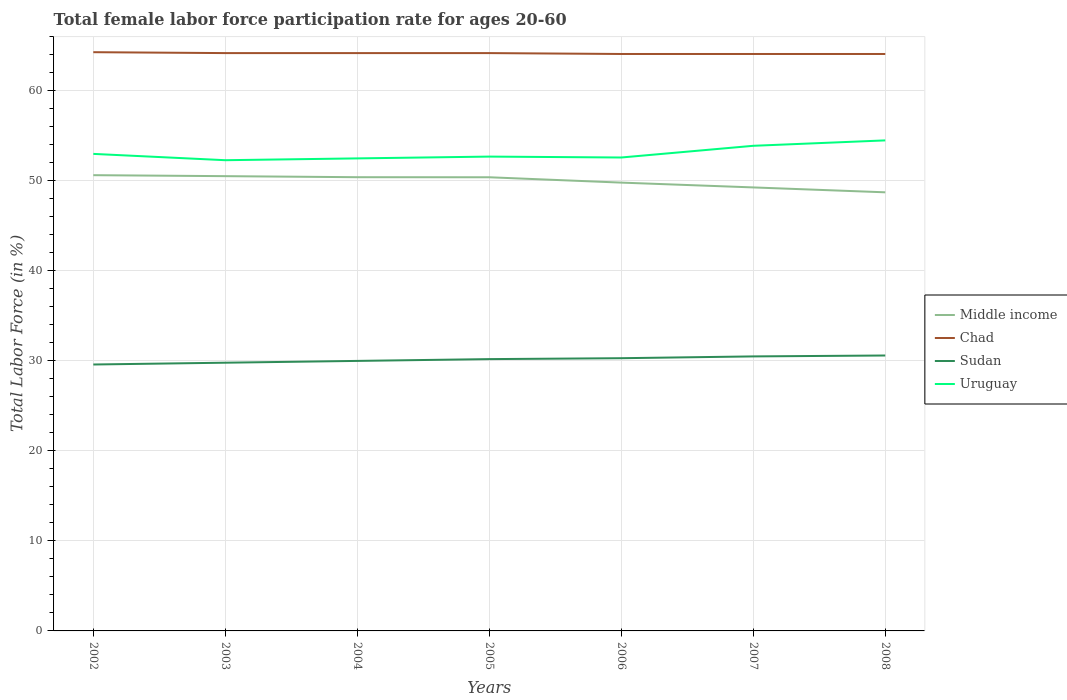How many different coloured lines are there?
Your response must be concise. 4. Does the line corresponding to Uruguay intersect with the line corresponding to Middle income?
Keep it short and to the point. No. Is the number of lines equal to the number of legend labels?
Provide a short and direct response. Yes. Across all years, what is the maximum female labor force participation rate in Chad?
Your answer should be compact. 64.1. What is the total female labor force participation rate in Middle income in the graph?
Offer a terse response. 0.01. What is the difference between the highest and the second highest female labor force participation rate in Chad?
Ensure brevity in your answer.  0.2. What is the difference between the highest and the lowest female labor force participation rate in Chad?
Keep it short and to the point. 4. Is the female labor force participation rate in Chad strictly greater than the female labor force participation rate in Middle income over the years?
Your answer should be very brief. No. Are the values on the major ticks of Y-axis written in scientific E-notation?
Ensure brevity in your answer.  No. Where does the legend appear in the graph?
Provide a succinct answer. Center right. How are the legend labels stacked?
Offer a terse response. Vertical. What is the title of the graph?
Your answer should be very brief. Total female labor force participation rate for ages 20-60. What is the label or title of the X-axis?
Ensure brevity in your answer.  Years. What is the Total Labor Force (in %) in Middle income in 2002?
Offer a very short reply. 50.64. What is the Total Labor Force (in %) in Chad in 2002?
Offer a terse response. 64.3. What is the Total Labor Force (in %) in Sudan in 2002?
Provide a short and direct response. 29.6. What is the Total Labor Force (in %) in Middle income in 2003?
Offer a very short reply. 50.53. What is the Total Labor Force (in %) in Chad in 2003?
Offer a terse response. 64.2. What is the Total Labor Force (in %) in Sudan in 2003?
Give a very brief answer. 29.8. What is the Total Labor Force (in %) of Uruguay in 2003?
Provide a short and direct response. 52.3. What is the Total Labor Force (in %) in Middle income in 2004?
Offer a very short reply. 50.41. What is the Total Labor Force (in %) of Chad in 2004?
Give a very brief answer. 64.2. What is the Total Labor Force (in %) of Sudan in 2004?
Provide a succinct answer. 30. What is the Total Labor Force (in %) in Uruguay in 2004?
Offer a terse response. 52.5. What is the Total Labor Force (in %) of Middle income in 2005?
Make the answer very short. 50.4. What is the Total Labor Force (in %) in Chad in 2005?
Offer a very short reply. 64.2. What is the Total Labor Force (in %) of Sudan in 2005?
Offer a very short reply. 30.2. What is the Total Labor Force (in %) in Uruguay in 2005?
Offer a terse response. 52.7. What is the Total Labor Force (in %) in Middle income in 2006?
Make the answer very short. 49.81. What is the Total Labor Force (in %) in Chad in 2006?
Keep it short and to the point. 64.1. What is the Total Labor Force (in %) in Sudan in 2006?
Provide a succinct answer. 30.3. What is the Total Labor Force (in %) of Uruguay in 2006?
Offer a very short reply. 52.6. What is the Total Labor Force (in %) of Middle income in 2007?
Offer a terse response. 49.28. What is the Total Labor Force (in %) of Chad in 2007?
Offer a terse response. 64.1. What is the Total Labor Force (in %) of Sudan in 2007?
Make the answer very short. 30.5. What is the Total Labor Force (in %) of Uruguay in 2007?
Make the answer very short. 53.9. What is the Total Labor Force (in %) of Middle income in 2008?
Your answer should be very brief. 48.73. What is the Total Labor Force (in %) in Chad in 2008?
Provide a succinct answer. 64.1. What is the Total Labor Force (in %) of Sudan in 2008?
Your answer should be compact. 30.6. What is the Total Labor Force (in %) in Uruguay in 2008?
Your answer should be very brief. 54.5. Across all years, what is the maximum Total Labor Force (in %) in Middle income?
Provide a succinct answer. 50.64. Across all years, what is the maximum Total Labor Force (in %) of Chad?
Your answer should be compact. 64.3. Across all years, what is the maximum Total Labor Force (in %) in Sudan?
Offer a terse response. 30.6. Across all years, what is the maximum Total Labor Force (in %) in Uruguay?
Provide a short and direct response. 54.5. Across all years, what is the minimum Total Labor Force (in %) of Middle income?
Provide a short and direct response. 48.73. Across all years, what is the minimum Total Labor Force (in %) in Chad?
Provide a short and direct response. 64.1. Across all years, what is the minimum Total Labor Force (in %) of Sudan?
Make the answer very short. 29.6. Across all years, what is the minimum Total Labor Force (in %) in Uruguay?
Your answer should be very brief. 52.3. What is the total Total Labor Force (in %) of Middle income in the graph?
Provide a short and direct response. 349.8. What is the total Total Labor Force (in %) in Chad in the graph?
Offer a terse response. 449.2. What is the total Total Labor Force (in %) of Sudan in the graph?
Your response must be concise. 211. What is the total Total Labor Force (in %) in Uruguay in the graph?
Ensure brevity in your answer.  371.5. What is the difference between the Total Labor Force (in %) in Middle income in 2002 and that in 2003?
Offer a very short reply. 0.11. What is the difference between the Total Labor Force (in %) of Uruguay in 2002 and that in 2003?
Provide a succinct answer. 0.7. What is the difference between the Total Labor Force (in %) of Middle income in 2002 and that in 2004?
Make the answer very short. 0.23. What is the difference between the Total Labor Force (in %) of Chad in 2002 and that in 2004?
Keep it short and to the point. 0.1. What is the difference between the Total Labor Force (in %) of Uruguay in 2002 and that in 2004?
Provide a short and direct response. 0.5. What is the difference between the Total Labor Force (in %) of Middle income in 2002 and that in 2005?
Your answer should be compact. 0.23. What is the difference between the Total Labor Force (in %) of Middle income in 2002 and that in 2006?
Keep it short and to the point. 0.83. What is the difference between the Total Labor Force (in %) in Middle income in 2002 and that in 2007?
Keep it short and to the point. 1.36. What is the difference between the Total Labor Force (in %) of Sudan in 2002 and that in 2007?
Keep it short and to the point. -0.9. What is the difference between the Total Labor Force (in %) of Uruguay in 2002 and that in 2007?
Your answer should be very brief. -0.9. What is the difference between the Total Labor Force (in %) of Middle income in 2002 and that in 2008?
Your answer should be compact. 1.9. What is the difference between the Total Labor Force (in %) of Sudan in 2002 and that in 2008?
Offer a very short reply. -1. What is the difference between the Total Labor Force (in %) of Middle income in 2003 and that in 2004?
Keep it short and to the point. 0.12. What is the difference between the Total Labor Force (in %) in Chad in 2003 and that in 2004?
Give a very brief answer. 0. What is the difference between the Total Labor Force (in %) of Sudan in 2003 and that in 2004?
Make the answer very short. -0.2. What is the difference between the Total Labor Force (in %) of Uruguay in 2003 and that in 2004?
Keep it short and to the point. -0.2. What is the difference between the Total Labor Force (in %) of Middle income in 2003 and that in 2005?
Your answer should be very brief. 0.12. What is the difference between the Total Labor Force (in %) in Chad in 2003 and that in 2005?
Offer a terse response. 0. What is the difference between the Total Labor Force (in %) of Middle income in 2003 and that in 2006?
Provide a succinct answer. 0.72. What is the difference between the Total Labor Force (in %) in Chad in 2003 and that in 2006?
Provide a succinct answer. 0.1. What is the difference between the Total Labor Force (in %) of Uruguay in 2003 and that in 2006?
Your answer should be compact. -0.3. What is the difference between the Total Labor Force (in %) in Middle income in 2003 and that in 2007?
Ensure brevity in your answer.  1.25. What is the difference between the Total Labor Force (in %) in Chad in 2003 and that in 2007?
Your answer should be compact. 0.1. What is the difference between the Total Labor Force (in %) in Sudan in 2003 and that in 2007?
Offer a terse response. -0.7. What is the difference between the Total Labor Force (in %) of Middle income in 2003 and that in 2008?
Make the answer very short. 1.8. What is the difference between the Total Labor Force (in %) of Chad in 2003 and that in 2008?
Keep it short and to the point. 0.1. What is the difference between the Total Labor Force (in %) of Sudan in 2003 and that in 2008?
Ensure brevity in your answer.  -0.8. What is the difference between the Total Labor Force (in %) of Middle income in 2004 and that in 2005?
Your answer should be very brief. 0.01. What is the difference between the Total Labor Force (in %) of Chad in 2004 and that in 2005?
Your response must be concise. 0. What is the difference between the Total Labor Force (in %) of Sudan in 2004 and that in 2005?
Offer a terse response. -0.2. What is the difference between the Total Labor Force (in %) of Middle income in 2004 and that in 2006?
Offer a terse response. 0.6. What is the difference between the Total Labor Force (in %) of Chad in 2004 and that in 2006?
Make the answer very short. 0.1. What is the difference between the Total Labor Force (in %) in Middle income in 2004 and that in 2007?
Keep it short and to the point. 1.14. What is the difference between the Total Labor Force (in %) in Sudan in 2004 and that in 2007?
Provide a short and direct response. -0.5. What is the difference between the Total Labor Force (in %) in Middle income in 2004 and that in 2008?
Offer a very short reply. 1.68. What is the difference between the Total Labor Force (in %) in Sudan in 2004 and that in 2008?
Offer a very short reply. -0.6. What is the difference between the Total Labor Force (in %) of Middle income in 2005 and that in 2006?
Your answer should be compact. 0.59. What is the difference between the Total Labor Force (in %) in Uruguay in 2005 and that in 2006?
Offer a terse response. 0.1. What is the difference between the Total Labor Force (in %) of Middle income in 2005 and that in 2007?
Make the answer very short. 1.13. What is the difference between the Total Labor Force (in %) in Chad in 2005 and that in 2007?
Provide a succinct answer. 0.1. What is the difference between the Total Labor Force (in %) of Middle income in 2005 and that in 2008?
Your answer should be compact. 1.67. What is the difference between the Total Labor Force (in %) of Chad in 2005 and that in 2008?
Your answer should be compact. 0.1. What is the difference between the Total Labor Force (in %) of Sudan in 2005 and that in 2008?
Your response must be concise. -0.4. What is the difference between the Total Labor Force (in %) of Uruguay in 2005 and that in 2008?
Your response must be concise. -1.8. What is the difference between the Total Labor Force (in %) of Middle income in 2006 and that in 2007?
Keep it short and to the point. 0.53. What is the difference between the Total Labor Force (in %) in Middle income in 2006 and that in 2008?
Provide a short and direct response. 1.08. What is the difference between the Total Labor Force (in %) in Sudan in 2006 and that in 2008?
Keep it short and to the point. -0.3. What is the difference between the Total Labor Force (in %) of Middle income in 2007 and that in 2008?
Offer a very short reply. 0.54. What is the difference between the Total Labor Force (in %) of Sudan in 2007 and that in 2008?
Make the answer very short. -0.1. What is the difference between the Total Labor Force (in %) of Middle income in 2002 and the Total Labor Force (in %) of Chad in 2003?
Your answer should be compact. -13.56. What is the difference between the Total Labor Force (in %) of Middle income in 2002 and the Total Labor Force (in %) of Sudan in 2003?
Your response must be concise. 20.84. What is the difference between the Total Labor Force (in %) in Middle income in 2002 and the Total Labor Force (in %) in Uruguay in 2003?
Your answer should be compact. -1.66. What is the difference between the Total Labor Force (in %) in Chad in 2002 and the Total Labor Force (in %) in Sudan in 2003?
Give a very brief answer. 34.5. What is the difference between the Total Labor Force (in %) of Chad in 2002 and the Total Labor Force (in %) of Uruguay in 2003?
Keep it short and to the point. 12. What is the difference between the Total Labor Force (in %) in Sudan in 2002 and the Total Labor Force (in %) in Uruguay in 2003?
Keep it short and to the point. -22.7. What is the difference between the Total Labor Force (in %) in Middle income in 2002 and the Total Labor Force (in %) in Chad in 2004?
Your answer should be very brief. -13.56. What is the difference between the Total Labor Force (in %) in Middle income in 2002 and the Total Labor Force (in %) in Sudan in 2004?
Your answer should be compact. 20.64. What is the difference between the Total Labor Force (in %) in Middle income in 2002 and the Total Labor Force (in %) in Uruguay in 2004?
Make the answer very short. -1.86. What is the difference between the Total Labor Force (in %) in Chad in 2002 and the Total Labor Force (in %) in Sudan in 2004?
Make the answer very short. 34.3. What is the difference between the Total Labor Force (in %) of Sudan in 2002 and the Total Labor Force (in %) of Uruguay in 2004?
Your response must be concise. -22.9. What is the difference between the Total Labor Force (in %) in Middle income in 2002 and the Total Labor Force (in %) in Chad in 2005?
Provide a succinct answer. -13.56. What is the difference between the Total Labor Force (in %) in Middle income in 2002 and the Total Labor Force (in %) in Sudan in 2005?
Your answer should be compact. 20.44. What is the difference between the Total Labor Force (in %) of Middle income in 2002 and the Total Labor Force (in %) of Uruguay in 2005?
Offer a terse response. -2.06. What is the difference between the Total Labor Force (in %) in Chad in 2002 and the Total Labor Force (in %) in Sudan in 2005?
Give a very brief answer. 34.1. What is the difference between the Total Labor Force (in %) of Chad in 2002 and the Total Labor Force (in %) of Uruguay in 2005?
Make the answer very short. 11.6. What is the difference between the Total Labor Force (in %) in Sudan in 2002 and the Total Labor Force (in %) in Uruguay in 2005?
Your response must be concise. -23.1. What is the difference between the Total Labor Force (in %) in Middle income in 2002 and the Total Labor Force (in %) in Chad in 2006?
Provide a short and direct response. -13.46. What is the difference between the Total Labor Force (in %) of Middle income in 2002 and the Total Labor Force (in %) of Sudan in 2006?
Offer a very short reply. 20.34. What is the difference between the Total Labor Force (in %) of Middle income in 2002 and the Total Labor Force (in %) of Uruguay in 2006?
Offer a very short reply. -1.96. What is the difference between the Total Labor Force (in %) of Chad in 2002 and the Total Labor Force (in %) of Sudan in 2006?
Provide a short and direct response. 34. What is the difference between the Total Labor Force (in %) in Sudan in 2002 and the Total Labor Force (in %) in Uruguay in 2006?
Your response must be concise. -23. What is the difference between the Total Labor Force (in %) in Middle income in 2002 and the Total Labor Force (in %) in Chad in 2007?
Your answer should be very brief. -13.46. What is the difference between the Total Labor Force (in %) of Middle income in 2002 and the Total Labor Force (in %) of Sudan in 2007?
Provide a short and direct response. 20.14. What is the difference between the Total Labor Force (in %) in Middle income in 2002 and the Total Labor Force (in %) in Uruguay in 2007?
Ensure brevity in your answer.  -3.26. What is the difference between the Total Labor Force (in %) in Chad in 2002 and the Total Labor Force (in %) in Sudan in 2007?
Offer a terse response. 33.8. What is the difference between the Total Labor Force (in %) in Sudan in 2002 and the Total Labor Force (in %) in Uruguay in 2007?
Offer a very short reply. -24.3. What is the difference between the Total Labor Force (in %) in Middle income in 2002 and the Total Labor Force (in %) in Chad in 2008?
Give a very brief answer. -13.46. What is the difference between the Total Labor Force (in %) in Middle income in 2002 and the Total Labor Force (in %) in Sudan in 2008?
Your answer should be compact. 20.04. What is the difference between the Total Labor Force (in %) in Middle income in 2002 and the Total Labor Force (in %) in Uruguay in 2008?
Offer a very short reply. -3.86. What is the difference between the Total Labor Force (in %) in Chad in 2002 and the Total Labor Force (in %) in Sudan in 2008?
Give a very brief answer. 33.7. What is the difference between the Total Labor Force (in %) in Sudan in 2002 and the Total Labor Force (in %) in Uruguay in 2008?
Your response must be concise. -24.9. What is the difference between the Total Labor Force (in %) of Middle income in 2003 and the Total Labor Force (in %) of Chad in 2004?
Make the answer very short. -13.67. What is the difference between the Total Labor Force (in %) of Middle income in 2003 and the Total Labor Force (in %) of Sudan in 2004?
Your answer should be very brief. 20.53. What is the difference between the Total Labor Force (in %) of Middle income in 2003 and the Total Labor Force (in %) of Uruguay in 2004?
Offer a very short reply. -1.97. What is the difference between the Total Labor Force (in %) of Chad in 2003 and the Total Labor Force (in %) of Sudan in 2004?
Your response must be concise. 34.2. What is the difference between the Total Labor Force (in %) in Sudan in 2003 and the Total Labor Force (in %) in Uruguay in 2004?
Ensure brevity in your answer.  -22.7. What is the difference between the Total Labor Force (in %) of Middle income in 2003 and the Total Labor Force (in %) of Chad in 2005?
Your response must be concise. -13.67. What is the difference between the Total Labor Force (in %) in Middle income in 2003 and the Total Labor Force (in %) in Sudan in 2005?
Your answer should be compact. 20.33. What is the difference between the Total Labor Force (in %) of Middle income in 2003 and the Total Labor Force (in %) of Uruguay in 2005?
Offer a very short reply. -2.17. What is the difference between the Total Labor Force (in %) of Sudan in 2003 and the Total Labor Force (in %) of Uruguay in 2005?
Your answer should be compact. -22.9. What is the difference between the Total Labor Force (in %) in Middle income in 2003 and the Total Labor Force (in %) in Chad in 2006?
Provide a succinct answer. -13.57. What is the difference between the Total Labor Force (in %) in Middle income in 2003 and the Total Labor Force (in %) in Sudan in 2006?
Make the answer very short. 20.23. What is the difference between the Total Labor Force (in %) of Middle income in 2003 and the Total Labor Force (in %) of Uruguay in 2006?
Keep it short and to the point. -2.07. What is the difference between the Total Labor Force (in %) of Chad in 2003 and the Total Labor Force (in %) of Sudan in 2006?
Offer a terse response. 33.9. What is the difference between the Total Labor Force (in %) in Sudan in 2003 and the Total Labor Force (in %) in Uruguay in 2006?
Keep it short and to the point. -22.8. What is the difference between the Total Labor Force (in %) of Middle income in 2003 and the Total Labor Force (in %) of Chad in 2007?
Provide a succinct answer. -13.57. What is the difference between the Total Labor Force (in %) in Middle income in 2003 and the Total Labor Force (in %) in Sudan in 2007?
Give a very brief answer. 20.03. What is the difference between the Total Labor Force (in %) in Middle income in 2003 and the Total Labor Force (in %) in Uruguay in 2007?
Give a very brief answer. -3.37. What is the difference between the Total Labor Force (in %) of Chad in 2003 and the Total Labor Force (in %) of Sudan in 2007?
Your answer should be compact. 33.7. What is the difference between the Total Labor Force (in %) in Chad in 2003 and the Total Labor Force (in %) in Uruguay in 2007?
Ensure brevity in your answer.  10.3. What is the difference between the Total Labor Force (in %) in Sudan in 2003 and the Total Labor Force (in %) in Uruguay in 2007?
Give a very brief answer. -24.1. What is the difference between the Total Labor Force (in %) in Middle income in 2003 and the Total Labor Force (in %) in Chad in 2008?
Give a very brief answer. -13.57. What is the difference between the Total Labor Force (in %) in Middle income in 2003 and the Total Labor Force (in %) in Sudan in 2008?
Provide a short and direct response. 19.93. What is the difference between the Total Labor Force (in %) in Middle income in 2003 and the Total Labor Force (in %) in Uruguay in 2008?
Provide a succinct answer. -3.97. What is the difference between the Total Labor Force (in %) in Chad in 2003 and the Total Labor Force (in %) in Sudan in 2008?
Your response must be concise. 33.6. What is the difference between the Total Labor Force (in %) of Sudan in 2003 and the Total Labor Force (in %) of Uruguay in 2008?
Keep it short and to the point. -24.7. What is the difference between the Total Labor Force (in %) of Middle income in 2004 and the Total Labor Force (in %) of Chad in 2005?
Make the answer very short. -13.79. What is the difference between the Total Labor Force (in %) in Middle income in 2004 and the Total Labor Force (in %) in Sudan in 2005?
Provide a short and direct response. 20.21. What is the difference between the Total Labor Force (in %) in Middle income in 2004 and the Total Labor Force (in %) in Uruguay in 2005?
Ensure brevity in your answer.  -2.29. What is the difference between the Total Labor Force (in %) in Chad in 2004 and the Total Labor Force (in %) in Sudan in 2005?
Keep it short and to the point. 34. What is the difference between the Total Labor Force (in %) of Sudan in 2004 and the Total Labor Force (in %) of Uruguay in 2005?
Your answer should be very brief. -22.7. What is the difference between the Total Labor Force (in %) of Middle income in 2004 and the Total Labor Force (in %) of Chad in 2006?
Keep it short and to the point. -13.69. What is the difference between the Total Labor Force (in %) in Middle income in 2004 and the Total Labor Force (in %) in Sudan in 2006?
Offer a very short reply. 20.11. What is the difference between the Total Labor Force (in %) of Middle income in 2004 and the Total Labor Force (in %) of Uruguay in 2006?
Offer a terse response. -2.19. What is the difference between the Total Labor Force (in %) of Chad in 2004 and the Total Labor Force (in %) of Sudan in 2006?
Give a very brief answer. 33.9. What is the difference between the Total Labor Force (in %) of Chad in 2004 and the Total Labor Force (in %) of Uruguay in 2006?
Give a very brief answer. 11.6. What is the difference between the Total Labor Force (in %) in Sudan in 2004 and the Total Labor Force (in %) in Uruguay in 2006?
Give a very brief answer. -22.6. What is the difference between the Total Labor Force (in %) in Middle income in 2004 and the Total Labor Force (in %) in Chad in 2007?
Provide a short and direct response. -13.69. What is the difference between the Total Labor Force (in %) of Middle income in 2004 and the Total Labor Force (in %) of Sudan in 2007?
Provide a succinct answer. 19.91. What is the difference between the Total Labor Force (in %) of Middle income in 2004 and the Total Labor Force (in %) of Uruguay in 2007?
Your response must be concise. -3.49. What is the difference between the Total Labor Force (in %) of Chad in 2004 and the Total Labor Force (in %) of Sudan in 2007?
Offer a very short reply. 33.7. What is the difference between the Total Labor Force (in %) in Sudan in 2004 and the Total Labor Force (in %) in Uruguay in 2007?
Ensure brevity in your answer.  -23.9. What is the difference between the Total Labor Force (in %) of Middle income in 2004 and the Total Labor Force (in %) of Chad in 2008?
Make the answer very short. -13.69. What is the difference between the Total Labor Force (in %) of Middle income in 2004 and the Total Labor Force (in %) of Sudan in 2008?
Give a very brief answer. 19.81. What is the difference between the Total Labor Force (in %) of Middle income in 2004 and the Total Labor Force (in %) of Uruguay in 2008?
Your answer should be very brief. -4.09. What is the difference between the Total Labor Force (in %) of Chad in 2004 and the Total Labor Force (in %) of Sudan in 2008?
Offer a very short reply. 33.6. What is the difference between the Total Labor Force (in %) of Sudan in 2004 and the Total Labor Force (in %) of Uruguay in 2008?
Your response must be concise. -24.5. What is the difference between the Total Labor Force (in %) of Middle income in 2005 and the Total Labor Force (in %) of Chad in 2006?
Your answer should be very brief. -13.7. What is the difference between the Total Labor Force (in %) in Middle income in 2005 and the Total Labor Force (in %) in Sudan in 2006?
Offer a very short reply. 20.1. What is the difference between the Total Labor Force (in %) in Middle income in 2005 and the Total Labor Force (in %) in Uruguay in 2006?
Your answer should be very brief. -2.2. What is the difference between the Total Labor Force (in %) of Chad in 2005 and the Total Labor Force (in %) of Sudan in 2006?
Your answer should be compact. 33.9. What is the difference between the Total Labor Force (in %) of Sudan in 2005 and the Total Labor Force (in %) of Uruguay in 2006?
Your answer should be compact. -22.4. What is the difference between the Total Labor Force (in %) of Middle income in 2005 and the Total Labor Force (in %) of Chad in 2007?
Provide a short and direct response. -13.7. What is the difference between the Total Labor Force (in %) of Middle income in 2005 and the Total Labor Force (in %) of Sudan in 2007?
Ensure brevity in your answer.  19.9. What is the difference between the Total Labor Force (in %) in Middle income in 2005 and the Total Labor Force (in %) in Uruguay in 2007?
Provide a succinct answer. -3.5. What is the difference between the Total Labor Force (in %) of Chad in 2005 and the Total Labor Force (in %) of Sudan in 2007?
Provide a succinct answer. 33.7. What is the difference between the Total Labor Force (in %) in Sudan in 2005 and the Total Labor Force (in %) in Uruguay in 2007?
Your answer should be compact. -23.7. What is the difference between the Total Labor Force (in %) in Middle income in 2005 and the Total Labor Force (in %) in Chad in 2008?
Your answer should be compact. -13.7. What is the difference between the Total Labor Force (in %) of Middle income in 2005 and the Total Labor Force (in %) of Sudan in 2008?
Provide a short and direct response. 19.8. What is the difference between the Total Labor Force (in %) in Middle income in 2005 and the Total Labor Force (in %) in Uruguay in 2008?
Your response must be concise. -4.1. What is the difference between the Total Labor Force (in %) in Chad in 2005 and the Total Labor Force (in %) in Sudan in 2008?
Offer a terse response. 33.6. What is the difference between the Total Labor Force (in %) of Sudan in 2005 and the Total Labor Force (in %) of Uruguay in 2008?
Your answer should be very brief. -24.3. What is the difference between the Total Labor Force (in %) in Middle income in 2006 and the Total Labor Force (in %) in Chad in 2007?
Your answer should be compact. -14.29. What is the difference between the Total Labor Force (in %) of Middle income in 2006 and the Total Labor Force (in %) of Sudan in 2007?
Ensure brevity in your answer.  19.31. What is the difference between the Total Labor Force (in %) of Middle income in 2006 and the Total Labor Force (in %) of Uruguay in 2007?
Provide a short and direct response. -4.09. What is the difference between the Total Labor Force (in %) in Chad in 2006 and the Total Labor Force (in %) in Sudan in 2007?
Provide a short and direct response. 33.6. What is the difference between the Total Labor Force (in %) of Sudan in 2006 and the Total Labor Force (in %) of Uruguay in 2007?
Offer a terse response. -23.6. What is the difference between the Total Labor Force (in %) in Middle income in 2006 and the Total Labor Force (in %) in Chad in 2008?
Provide a succinct answer. -14.29. What is the difference between the Total Labor Force (in %) of Middle income in 2006 and the Total Labor Force (in %) of Sudan in 2008?
Provide a succinct answer. 19.21. What is the difference between the Total Labor Force (in %) in Middle income in 2006 and the Total Labor Force (in %) in Uruguay in 2008?
Provide a succinct answer. -4.69. What is the difference between the Total Labor Force (in %) of Chad in 2006 and the Total Labor Force (in %) of Sudan in 2008?
Keep it short and to the point. 33.5. What is the difference between the Total Labor Force (in %) of Sudan in 2006 and the Total Labor Force (in %) of Uruguay in 2008?
Provide a short and direct response. -24.2. What is the difference between the Total Labor Force (in %) of Middle income in 2007 and the Total Labor Force (in %) of Chad in 2008?
Offer a very short reply. -14.82. What is the difference between the Total Labor Force (in %) of Middle income in 2007 and the Total Labor Force (in %) of Sudan in 2008?
Give a very brief answer. 18.68. What is the difference between the Total Labor Force (in %) of Middle income in 2007 and the Total Labor Force (in %) of Uruguay in 2008?
Offer a terse response. -5.22. What is the difference between the Total Labor Force (in %) in Chad in 2007 and the Total Labor Force (in %) in Sudan in 2008?
Provide a short and direct response. 33.5. What is the difference between the Total Labor Force (in %) of Chad in 2007 and the Total Labor Force (in %) of Uruguay in 2008?
Your answer should be very brief. 9.6. What is the average Total Labor Force (in %) of Middle income per year?
Give a very brief answer. 49.97. What is the average Total Labor Force (in %) of Chad per year?
Offer a terse response. 64.17. What is the average Total Labor Force (in %) of Sudan per year?
Your answer should be compact. 30.14. What is the average Total Labor Force (in %) in Uruguay per year?
Your answer should be compact. 53.07. In the year 2002, what is the difference between the Total Labor Force (in %) in Middle income and Total Labor Force (in %) in Chad?
Provide a succinct answer. -13.66. In the year 2002, what is the difference between the Total Labor Force (in %) of Middle income and Total Labor Force (in %) of Sudan?
Ensure brevity in your answer.  21.04. In the year 2002, what is the difference between the Total Labor Force (in %) of Middle income and Total Labor Force (in %) of Uruguay?
Your response must be concise. -2.36. In the year 2002, what is the difference between the Total Labor Force (in %) of Chad and Total Labor Force (in %) of Sudan?
Provide a succinct answer. 34.7. In the year 2002, what is the difference between the Total Labor Force (in %) in Chad and Total Labor Force (in %) in Uruguay?
Provide a short and direct response. 11.3. In the year 2002, what is the difference between the Total Labor Force (in %) of Sudan and Total Labor Force (in %) of Uruguay?
Give a very brief answer. -23.4. In the year 2003, what is the difference between the Total Labor Force (in %) in Middle income and Total Labor Force (in %) in Chad?
Offer a very short reply. -13.67. In the year 2003, what is the difference between the Total Labor Force (in %) in Middle income and Total Labor Force (in %) in Sudan?
Give a very brief answer. 20.73. In the year 2003, what is the difference between the Total Labor Force (in %) in Middle income and Total Labor Force (in %) in Uruguay?
Make the answer very short. -1.77. In the year 2003, what is the difference between the Total Labor Force (in %) in Chad and Total Labor Force (in %) in Sudan?
Provide a succinct answer. 34.4. In the year 2003, what is the difference between the Total Labor Force (in %) of Chad and Total Labor Force (in %) of Uruguay?
Provide a short and direct response. 11.9. In the year 2003, what is the difference between the Total Labor Force (in %) in Sudan and Total Labor Force (in %) in Uruguay?
Provide a short and direct response. -22.5. In the year 2004, what is the difference between the Total Labor Force (in %) of Middle income and Total Labor Force (in %) of Chad?
Provide a succinct answer. -13.79. In the year 2004, what is the difference between the Total Labor Force (in %) in Middle income and Total Labor Force (in %) in Sudan?
Keep it short and to the point. 20.41. In the year 2004, what is the difference between the Total Labor Force (in %) in Middle income and Total Labor Force (in %) in Uruguay?
Your answer should be very brief. -2.09. In the year 2004, what is the difference between the Total Labor Force (in %) of Chad and Total Labor Force (in %) of Sudan?
Make the answer very short. 34.2. In the year 2004, what is the difference between the Total Labor Force (in %) in Chad and Total Labor Force (in %) in Uruguay?
Your response must be concise. 11.7. In the year 2004, what is the difference between the Total Labor Force (in %) in Sudan and Total Labor Force (in %) in Uruguay?
Make the answer very short. -22.5. In the year 2005, what is the difference between the Total Labor Force (in %) of Middle income and Total Labor Force (in %) of Chad?
Your response must be concise. -13.8. In the year 2005, what is the difference between the Total Labor Force (in %) in Middle income and Total Labor Force (in %) in Sudan?
Your response must be concise. 20.2. In the year 2005, what is the difference between the Total Labor Force (in %) in Middle income and Total Labor Force (in %) in Uruguay?
Your answer should be compact. -2.3. In the year 2005, what is the difference between the Total Labor Force (in %) in Chad and Total Labor Force (in %) in Sudan?
Make the answer very short. 34. In the year 2005, what is the difference between the Total Labor Force (in %) in Chad and Total Labor Force (in %) in Uruguay?
Offer a very short reply. 11.5. In the year 2005, what is the difference between the Total Labor Force (in %) of Sudan and Total Labor Force (in %) of Uruguay?
Ensure brevity in your answer.  -22.5. In the year 2006, what is the difference between the Total Labor Force (in %) of Middle income and Total Labor Force (in %) of Chad?
Offer a terse response. -14.29. In the year 2006, what is the difference between the Total Labor Force (in %) in Middle income and Total Labor Force (in %) in Sudan?
Offer a very short reply. 19.51. In the year 2006, what is the difference between the Total Labor Force (in %) in Middle income and Total Labor Force (in %) in Uruguay?
Your answer should be very brief. -2.79. In the year 2006, what is the difference between the Total Labor Force (in %) of Chad and Total Labor Force (in %) of Sudan?
Ensure brevity in your answer.  33.8. In the year 2006, what is the difference between the Total Labor Force (in %) in Chad and Total Labor Force (in %) in Uruguay?
Provide a succinct answer. 11.5. In the year 2006, what is the difference between the Total Labor Force (in %) in Sudan and Total Labor Force (in %) in Uruguay?
Give a very brief answer. -22.3. In the year 2007, what is the difference between the Total Labor Force (in %) in Middle income and Total Labor Force (in %) in Chad?
Keep it short and to the point. -14.82. In the year 2007, what is the difference between the Total Labor Force (in %) in Middle income and Total Labor Force (in %) in Sudan?
Offer a very short reply. 18.78. In the year 2007, what is the difference between the Total Labor Force (in %) in Middle income and Total Labor Force (in %) in Uruguay?
Keep it short and to the point. -4.62. In the year 2007, what is the difference between the Total Labor Force (in %) in Chad and Total Labor Force (in %) in Sudan?
Your answer should be compact. 33.6. In the year 2007, what is the difference between the Total Labor Force (in %) of Chad and Total Labor Force (in %) of Uruguay?
Your response must be concise. 10.2. In the year 2007, what is the difference between the Total Labor Force (in %) in Sudan and Total Labor Force (in %) in Uruguay?
Your response must be concise. -23.4. In the year 2008, what is the difference between the Total Labor Force (in %) of Middle income and Total Labor Force (in %) of Chad?
Offer a very short reply. -15.37. In the year 2008, what is the difference between the Total Labor Force (in %) in Middle income and Total Labor Force (in %) in Sudan?
Ensure brevity in your answer.  18.13. In the year 2008, what is the difference between the Total Labor Force (in %) of Middle income and Total Labor Force (in %) of Uruguay?
Offer a very short reply. -5.77. In the year 2008, what is the difference between the Total Labor Force (in %) of Chad and Total Labor Force (in %) of Sudan?
Offer a very short reply. 33.5. In the year 2008, what is the difference between the Total Labor Force (in %) in Chad and Total Labor Force (in %) in Uruguay?
Ensure brevity in your answer.  9.6. In the year 2008, what is the difference between the Total Labor Force (in %) in Sudan and Total Labor Force (in %) in Uruguay?
Offer a very short reply. -23.9. What is the ratio of the Total Labor Force (in %) in Uruguay in 2002 to that in 2003?
Give a very brief answer. 1.01. What is the ratio of the Total Labor Force (in %) in Middle income in 2002 to that in 2004?
Give a very brief answer. 1. What is the ratio of the Total Labor Force (in %) in Sudan in 2002 to that in 2004?
Your answer should be compact. 0.99. What is the ratio of the Total Labor Force (in %) in Uruguay in 2002 to that in 2004?
Provide a succinct answer. 1.01. What is the ratio of the Total Labor Force (in %) of Middle income in 2002 to that in 2005?
Offer a very short reply. 1. What is the ratio of the Total Labor Force (in %) of Chad in 2002 to that in 2005?
Offer a very short reply. 1. What is the ratio of the Total Labor Force (in %) of Sudan in 2002 to that in 2005?
Your answer should be very brief. 0.98. What is the ratio of the Total Labor Force (in %) in Middle income in 2002 to that in 2006?
Keep it short and to the point. 1.02. What is the ratio of the Total Labor Force (in %) in Chad in 2002 to that in 2006?
Ensure brevity in your answer.  1. What is the ratio of the Total Labor Force (in %) of Sudan in 2002 to that in 2006?
Your answer should be compact. 0.98. What is the ratio of the Total Labor Force (in %) of Uruguay in 2002 to that in 2006?
Keep it short and to the point. 1.01. What is the ratio of the Total Labor Force (in %) in Middle income in 2002 to that in 2007?
Keep it short and to the point. 1.03. What is the ratio of the Total Labor Force (in %) in Sudan in 2002 to that in 2007?
Offer a very short reply. 0.97. What is the ratio of the Total Labor Force (in %) of Uruguay in 2002 to that in 2007?
Make the answer very short. 0.98. What is the ratio of the Total Labor Force (in %) in Middle income in 2002 to that in 2008?
Your response must be concise. 1.04. What is the ratio of the Total Labor Force (in %) in Chad in 2002 to that in 2008?
Provide a succinct answer. 1. What is the ratio of the Total Labor Force (in %) in Sudan in 2002 to that in 2008?
Provide a succinct answer. 0.97. What is the ratio of the Total Labor Force (in %) in Uruguay in 2002 to that in 2008?
Offer a very short reply. 0.97. What is the ratio of the Total Labor Force (in %) of Chad in 2003 to that in 2004?
Your response must be concise. 1. What is the ratio of the Total Labor Force (in %) of Uruguay in 2003 to that in 2004?
Your response must be concise. 1. What is the ratio of the Total Labor Force (in %) in Middle income in 2003 to that in 2005?
Offer a very short reply. 1. What is the ratio of the Total Labor Force (in %) in Chad in 2003 to that in 2005?
Your answer should be compact. 1. What is the ratio of the Total Labor Force (in %) in Sudan in 2003 to that in 2005?
Offer a very short reply. 0.99. What is the ratio of the Total Labor Force (in %) in Middle income in 2003 to that in 2006?
Your answer should be compact. 1.01. What is the ratio of the Total Labor Force (in %) of Sudan in 2003 to that in 2006?
Keep it short and to the point. 0.98. What is the ratio of the Total Labor Force (in %) in Middle income in 2003 to that in 2007?
Offer a terse response. 1.03. What is the ratio of the Total Labor Force (in %) of Uruguay in 2003 to that in 2007?
Your response must be concise. 0.97. What is the ratio of the Total Labor Force (in %) of Middle income in 2003 to that in 2008?
Provide a short and direct response. 1.04. What is the ratio of the Total Labor Force (in %) of Sudan in 2003 to that in 2008?
Your answer should be compact. 0.97. What is the ratio of the Total Labor Force (in %) in Uruguay in 2003 to that in 2008?
Keep it short and to the point. 0.96. What is the ratio of the Total Labor Force (in %) of Middle income in 2004 to that in 2005?
Your answer should be compact. 1. What is the ratio of the Total Labor Force (in %) of Chad in 2004 to that in 2005?
Provide a succinct answer. 1. What is the ratio of the Total Labor Force (in %) in Sudan in 2004 to that in 2005?
Provide a succinct answer. 0.99. What is the ratio of the Total Labor Force (in %) of Middle income in 2004 to that in 2006?
Make the answer very short. 1.01. What is the ratio of the Total Labor Force (in %) in Chad in 2004 to that in 2006?
Your answer should be very brief. 1. What is the ratio of the Total Labor Force (in %) in Sudan in 2004 to that in 2006?
Your answer should be compact. 0.99. What is the ratio of the Total Labor Force (in %) in Sudan in 2004 to that in 2007?
Your answer should be very brief. 0.98. What is the ratio of the Total Labor Force (in %) of Middle income in 2004 to that in 2008?
Your answer should be compact. 1.03. What is the ratio of the Total Labor Force (in %) in Sudan in 2004 to that in 2008?
Ensure brevity in your answer.  0.98. What is the ratio of the Total Labor Force (in %) of Uruguay in 2004 to that in 2008?
Keep it short and to the point. 0.96. What is the ratio of the Total Labor Force (in %) in Middle income in 2005 to that in 2006?
Keep it short and to the point. 1.01. What is the ratio of the Total Labor Force (in %) of Uruguay in 2005 to that in 2006?
Keep it short and to the point. 1. What is the ratio of the Total Labor Force (in %) in Middle income in 2005 to that in 2007?
Your answer should be very brief. 1.02. What is the ratio of the Total Labor Force (in %) of Chad in 2005 to that in 2007?
Offer a terse response. 1. What is the ratio of the Total Labor Force (in %) of Sudan in 2005 to that in 2007?
Provide a succinct answer. 0.99. What is the ratio of the Total Labor Force (in %) of Uruguay in 2005 to that in 2007?
Give a very brief answer. 0.98. What is the ratio of the Total Labor Force (in %) of Middle income in 2005 to that in 2008?
Provide a succinct answer. 1.03. What is the ratio of the Total Labor Force (in %) of Chad in 2005 to that in 2008?
Your answer should be very brief. 1. What is the ratio of the Total Labor Force (in %) of Sudan in 2005 to that in 2008?
Give a very brief answer. 0.99. What is the ratio of the Total Labor Force (in %) in Middle income in 2006 to that in 2007?
Your answer should be very brief. 1.01. What is the ratio of the Total Labor Force (in %) in Chad in 2006 to that in 2007?
Provide a short and direct response. 1. What is the ratio of the Total Labor Force (in %) of Sudan in 2006 to that in 2007?
Provide a succinct answer. 0.99. What is the ratio of the Total Labor Force (in %) in Uruguay in 2006 to that in 2007?
Make the answer very short. 0.98. What is the ratio of the Total Labor Force (in %) of Middle income in 2006 to that in 2008?
Provide a short and direct response. 1.02. What is the ratio of the Total Labor Force (in %) of Sudan in 2006 to that in 2008?
Your response must be concise. 0.99. What is the ratio of the Total Labor Force (in %) in Uruguay in 2006 to that in 2008?
Your answer should be very brief. 0.97. What is the ratio of the Total Labor Force (in %) in Middle income in 2007 to that in 2008?
Provide a short and direct response. 1.01. What is the ratio of the Total Labor Force (in %) of Sudan in 2007 to that in 2008?
Offer a terse response. 1. What is the difference between the highest and the second highest Total Labor Force (in %) in Middle income?
Keep it short and to the point. 0.11. What is the difference between the highest and the lowest Total Labor Force (in %) of Middle income?
Your response must be concise. 1.9. What is the difference between the highest and the lowest Total Labor Force (in %) in Chad?
Your answer should be very brief. 0.2. What is the difference between the highest and the lowest Total Labor Force (in %) of Uruguay?
Provide a succinct answer. 2.2. 